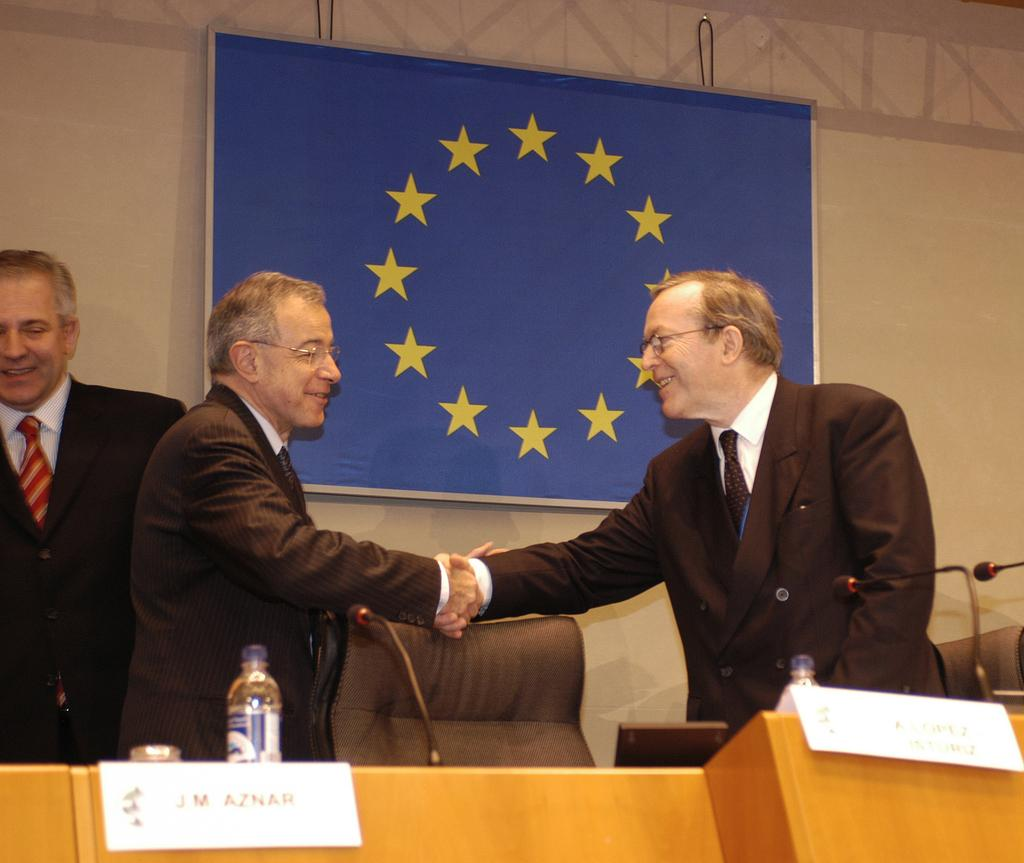What is happening between the man and another person in the image? The man is shaking hands with another person in the image. What are the individuals wearing in the image? Both individuals are wearing coats in the image. What object can be seen on a table in the image? There is a water bottle on a table in the image. How many eyes does the sister have in the image? There is no mention of a sister or eyes in the image; it only features a man shaking hands with another person and a water bottle on a table. 